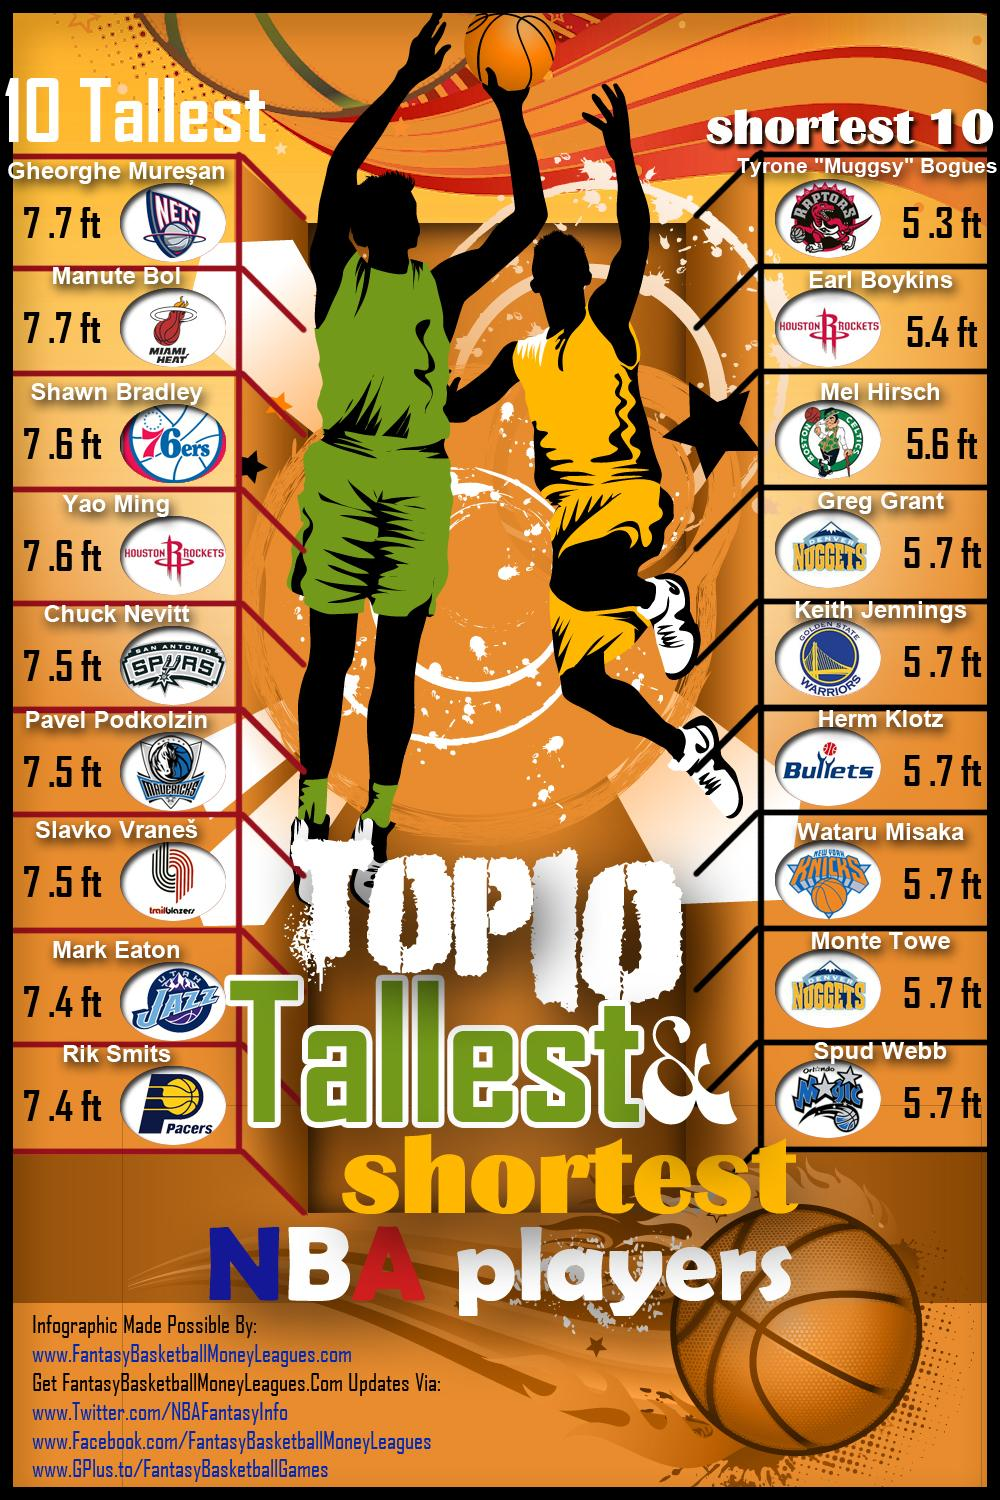Outline some significant characteristics in this image. Yao Ming and Earl Boykins are both members of the Houston Rockets. Shawn Bradley is a player who belongs to the Philadelphia 76ers. Earl Boykins is a member of the Houston Rockets team. Greg Grant plays for the Denver Nuggets basketball team. The most common height among the shortest 10 is 5.7 feet. 